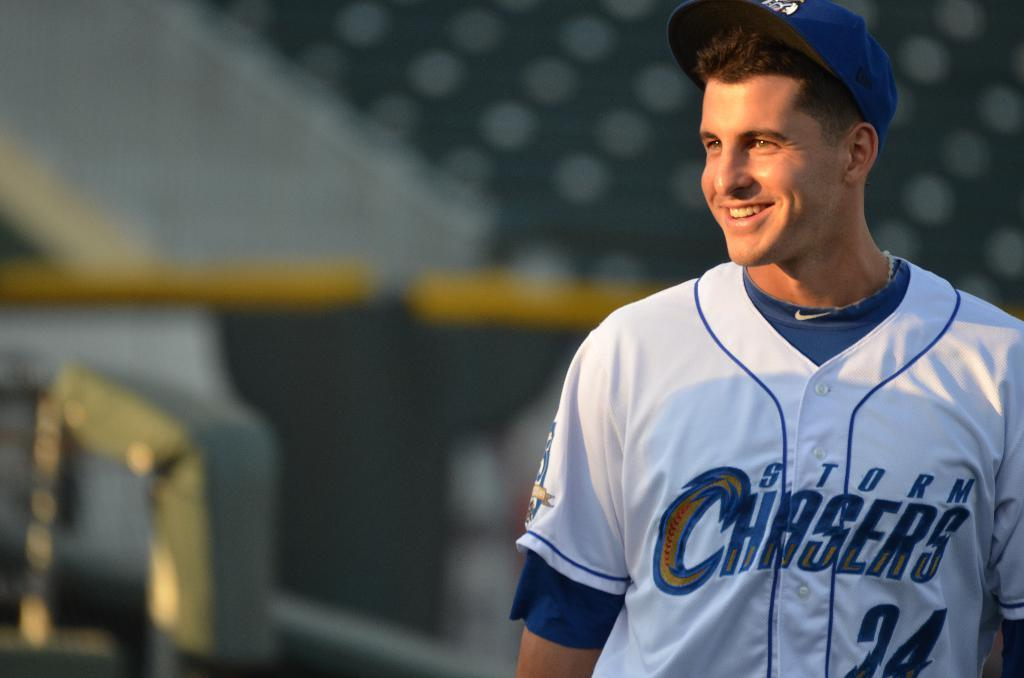Provide a one-sentence caption for the provided image. A baseball player wearing a Storm Chasers jersey smiles on the field. 